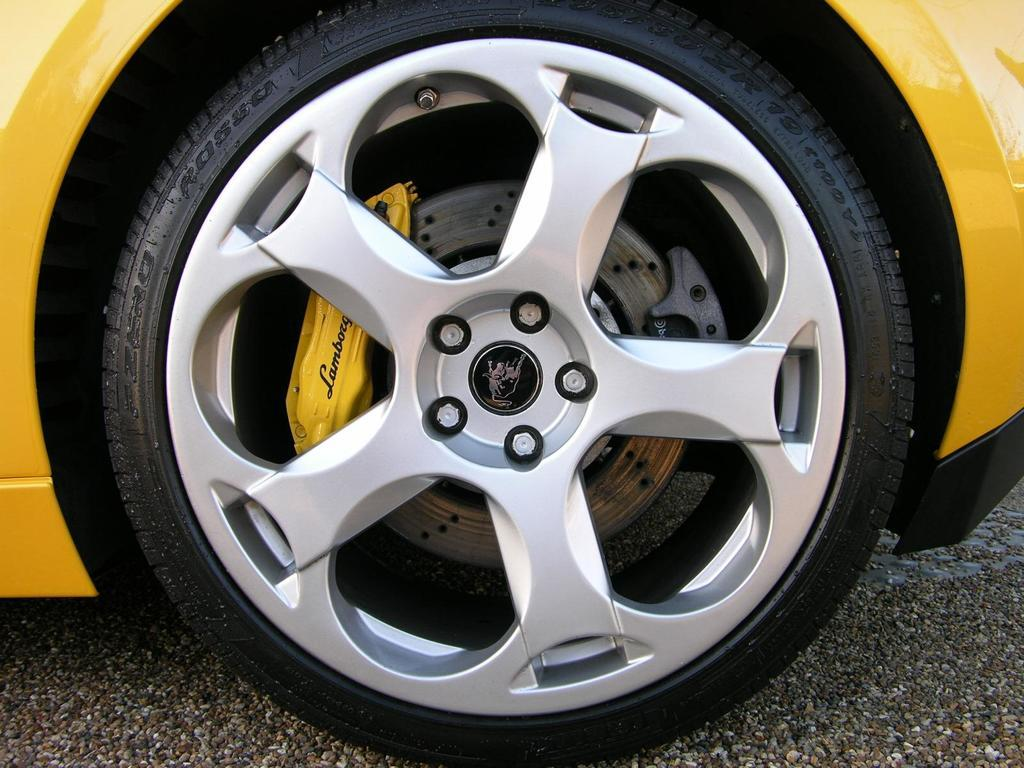What color is the car that is visible in the image? There is a yellow color car in the image. What part of the car is black? The car has black tires. Where is the car located in the image? The car is on the road. What reason does the car have for being on the road in the image? The image does not provide any information about the reason for the car being on the road. Can you see the car kissing another car in the image? There is no indication of any cars kissing in the image. 